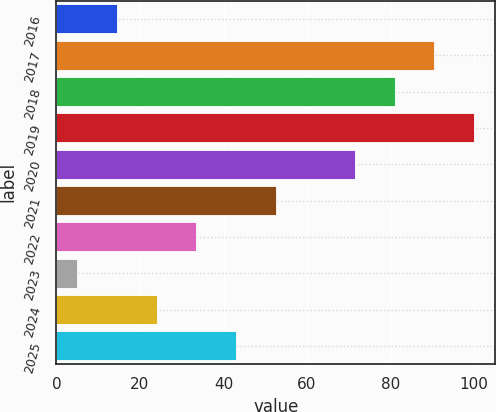<chart> <loc_0><loc_0><loc_500><loc_500><bar_chart><fcel>2016<fcel>2017<fcel>2018<fcel>2019<fcel>2020<fcel>2021<fcel>2022<fcel>2023<fcel>2024<fcel>2025<nl><fcel>14.5<fcel>90.5<fcel>81<fcel>100<fcel>71.5<fcel>52.5<fcel>33.5<fcel>5<fcel>24<fcel>43<nl></chart> 